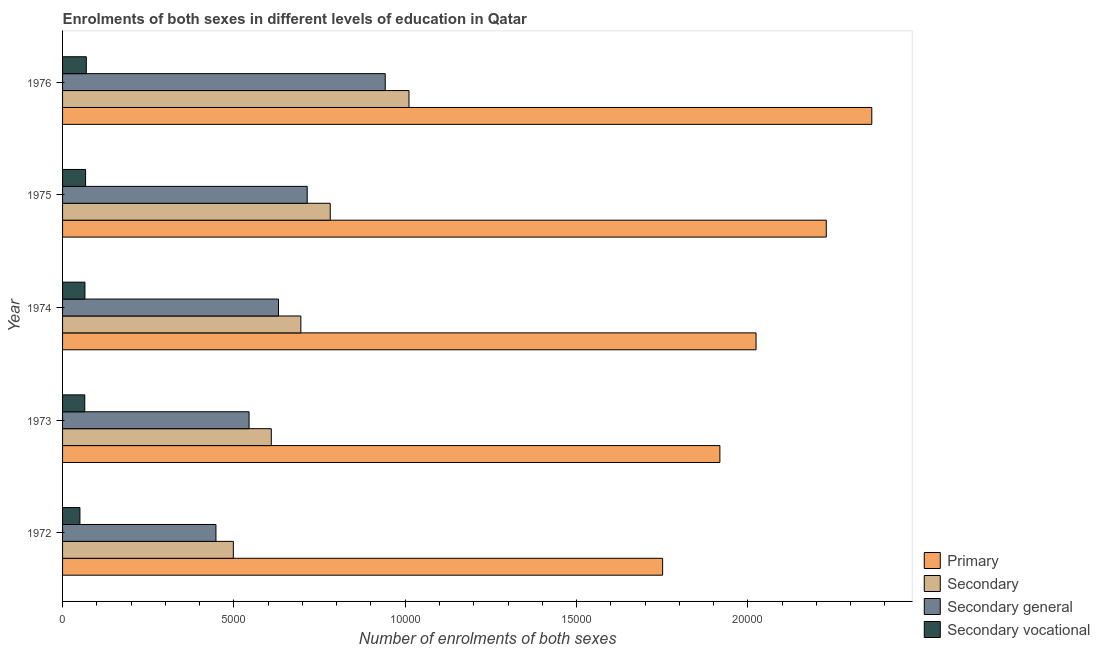Are the number of bars on each tick of the Y-axis equal?
Your answer should be very brief. Yes. How many bars are there on the 4th tick from the top?
Provide a short and direct response. 4. How many bars are there on the 4th tick from the bottom?
Ensure brevity in your answer.  4. What is the label of the 4th group of bars from the top?
Your answer should be very brief. 1973. What is the number of enrolments in secondary vocational education in 1975?
Provide a succinct answer. 672. Across all years, what is the maximum number of enrolments in secondary general education?
Make the answer very short. 9416. Across all years, what is the minimum number of enrolments in secondary general education?
Your answer should be very brief. 4476. In which year was the number of enrolments in primary education maximum?
Offer a very short reply. 1976. In which year was the number of enrolments in secondary general education minimum?
Make the answer very short. 1972. What is the total number of enrolments in secondary education in the graph?
Keep it short and to the point. 3.59e+04. What is the difference between the number of enrolments in secondary vocational education in 1974 and that in 1976?
Make the answer very short. -40. What is the difference between the number of enrolments in secondary vocational education in 1972 and the number of enrolments in primary education in 1974?
Offer a very short reply. -1.97e+04. What is the average number of enrolments in secondary general education per year?
Provide a short and direct response. 6555. In the year 1973, what is the difference between the number of enrolments in secondary education and number of enrolments in primary education?
Keep it short and to the point. -1.31e+04. In how many years, is the number of enrolments in primary education greater than 9000 ?
Provide a succinct answer. 5. What is the ratio of the number of enrolments in primary education in 1973 to that in 1974?
Provide a succinct answer. 0.95. What is the difference between the highest and the second highest number of enrolments in secondary education?
Give a very brief answer. 2298. What is the difference between the highest and the lowest number of enrolments in secondary education?
Make the answer very short. 5126. In how many years, is the number of enrolments in secondary education greater than the average number of enrolments in secondary education taken over all years?
Provide a succinct answer. 2. Is it the case that in every year, the sum of the number of enrolments in primary education and number of enrolments in secondary education is greater than the sum of number of enrolments in secondary vocational education and number of enrolments in secondary general education?
Make the answer very short. No. What does the 4th bar from the top in 1974 represents?
Make the answer very short. Primary. What does the 4th bar from the bottom in 1974 represents?
Provide a succinct answer. Secondary vocational. Are all the bars in the graph horizontal?
Keep it short and to the point. Yes. How many years are there in the graph?
Offer a terse response. 5. What is the difference between two consecutive major ticks on the X-axis?
Your answer should be compact. 5000. Are the values on the major ticks of X-axis written in scientific E-notation?
Provide a short and direct response. No. Does the graph contain any zero values?
Offer a terse response. No. Does the graph contain grids?
Offer a very short reply. No. How are the legend labels stacked?
Keep it short and to the point. Vertical. What is the title of the graph?
Provide a succinct answer. Enrolments of both sexes in different levels of education in Qatar. What is the label or title of the X-axis?
Keep it short and to the point. Number of enrolments of both sexes. What is the Number of enrolments of both sexes of Primary in 1972?
Offer a terse response. 1.75e+04. What is the Number of enrolments of both sexes of Secondary in 1972?
Provide a short and direct response. 4983. What is the Number of enrolments of both sexes of Secondary general in 1972?
Offer a very short reply. 4476. What is the Number of enrolments of both sexes of Secondary vocational in 1972?
Ensure brevity in your answer.  507. What is the Number of enrolments of both sexes of Primary in 1973?
Make the answer very short. 1.92e+04. What is the Number of enrolments of both sexes in Secondary in 1973?
Keep it short and to the point. 6091. What is the Number of enrolments of both sexes of Secondary general in 1973?
Provide a succinct answer. 5443. What is the Number of enrolments of both sexes in Secondary vocational in 1973?
Your response must be concise. 648. What is the Number of enrolments of both sexes in Primary in 1974?
Offer a very short reply. 2.02e+04. What is the Number of enrolments of both sexes in Secondary in 1974?
Your answer should be very brief. 6954. What is the Number of enrolments of both sexes of Secondary general in 1974?
Your answer should be very brief. 6301. What is the Number of enrolments of both sexes in Secondary vocational in 1974?
Your answer should be very brief. 653. What is the Number of enrolments of both sexes in Primary in 1975?
Offer a terse response. 2.23e+04. What is the Number of enrolments of both sexes in Secondary in 1975?
Your answer should be compact. 7811. What is the Number of enrolments of both sexes in Secondary general in 1975?
Provide a succinct answer. 7139. What is the Number of enrolments of both sexes of Secondary vocational in 1975?
Ensure brevity in your answer.  672. What is the Number of enrolments of both sexes in Primary in 1976?
Your response must be concise. 2.36e+04. What is the Number of enrolments of both sexes of Secondary in 1976?
Give a very brief answer. 1.01e+04. What is the Number of enrolments of both sexes of Secondary general in 1976?
Your answer should be very brief. 9416. What is the Number of enrolments of both sexes of Secondary vocational in 1976?
Give a very brief answer. 693. Across all years, what is the maximum Number of enrolments of both sexes in Primary?
Keep it short and to the point. 2.36e+04. Across all years, what is the maximum Number of enrolments of both sexes in Secondary?
Your answer should be compact. 1.01e+04. Across all years, what is the maximum Number of enrolments of both sexes of Secondary general?
Your answer should be very brief. 9416. Across all years, what is the maximum Number of enrolments of both sexes in Secondary vocational?
Offer a very short reply. 693. Across all years, what is the minimum Number of enrolments of both sexes in Primary?
Your answer should be very brief. 1.75e+04. Across all years, what is the minimum Number of enrolments of both sexes of Secondary?
Make the answer very short. 4983. Across all years, what is the minimum Number of enrolments of both sexes of Secondary general?
Provide a short and direct response. 4476. Across all years, what is the minimum Number of enrolments of both sexes of Secondary vocational?
Offer a very short reply. 507. What is the total Number of enrolments of both sexes of Primary in the graph?
Make the answer very short. 1.03e+05. What is the total Number of enrolments of both sexes of Secondary in the graph?
Your answer should be compact. 3.59e+04. What is the total Number of enrolments of both sexes of Secondary general in the graph?
Make the answer very short. 3.28e+04. What is the total Number of enrolments of both sexes of Secondary vocational in the graph?
Give a very brief answer. 3173. What is the difference between the Number of enrolments of both sexes in Primary in 1972 and that in 1973?
Keep it short and to the point. -1671. What is the difference between the Number of enrolments of both sexes in Secondary in 1972 and that in 1973?
Offer a terse response. -1108. What is the difference between the Number of enrolments of both sexes of Secondary general in 1972 and that in 1973?
Your response must be concise. -967. What is the difference between the Number of enrolments of both sexes in Secondary vocational in 1972 and that in 1973?
Ensure brevity in your answer.  -141. What is the difference between the Number of enrolments of both sexes of Primary in 1972 and that in 1974?
Your response must be concise. -2726. What is the difference between the Number of enrolments of both sexes in Secondary in 1972 and that in 1974?
Provide a short and direct response. -1971. What is the difference between the Number of enrolments of both sexes in Secondary general in 1972 and that in 1974?
Provide a short and direct response. -1825. What is the difference between the Number of enrolments of both sexes in Secondary vocational in 1972 and that in 1974?
Your answer should be compact. -146. What is the difference between the Number of enrolments of both sexes in Primary in 1972 and that in 1975?
Your response must be concise. -4776. What is the difference between the Number of enrolments of both sexes of Secondary in 1972 and that in 1975?
Your answer should be compact. -2828. What is the difference between the Number of enrolments of both sexes of Secondary general in 1972 and that in 1975?
Offer a terse response. -2663. What is the difference between the Number of enrolments of both sexes in Secondary vocational in 1972 and that in 1975?
Offer a terse response. -165. What is the difference between the Number of enrolments of both sexes in Primary in 1972 and that in 1976?
Keep it short and to the point. -6104. What is the difference between the Number of enrolments of both sexes in Secondary in 1972 and that in 1976?
Offer a terse response. -5126. What is the difference between the Number of enrolments of both sexes of Secondary general in 1972 and that in 1976?
Provide a succinct answer. -4940. What is the difference between the Number of enrolments of both sexes of Secondary vocational in 1972 and that in 1976?
Make the answer very short. -186. What is the difference between the Number of enrolments of both sexes of Primary in 1973 and that in 1974?
Offer a terse response. -1055. What is the difference between the Number of enrolments of both sexes in Secondary in 1973 and that in 1974?
Keep it short and to the point. -863. What is the difference between the Number of enrolments of both sexes in Secondary general in 1973 and that in 1974?
Provide a short and direct response. -858. What is the difference between the Number of enrolments of both sexes of Primary in 1973 and that in 1975?
Ensure brevity in your answer.  -3105. What is the difference between the Number of enrolments of both sexes in Secondary in 1973 and that in 1975?
Provide a succinct answer. -1720. What is the difference between the Number of enrolments of both sexes in Secondary general in 1973 and that in 1975?
Offer a very short reply. -1696. What is the difference between the Number of enrolments of both sexes in Secondary vocational in 1973 and that in 1975?
Ensure brevity in your answer.  -24. What is the difference between the Number of enrolments of both sexes in Primary in 1973 and that in 1976?
Provide a short and direct response. -4433. What is the difference between the Number of enrolments of both sexes of Secondary in 1973 and that in 1976?
Your answer should be very brief. -4018. What is the difference between the Number of enrolments of both sexes of Secondary general in 1973 and that in 1976?
Provide a succinct answer. -3973. What is the difference between the Number of enrolments of both sexes of Secondary vocational in 1973 and that in 1976?
Offer a very short reply. -45. What is the difference between the Number of enrolments of both sexes of Primary in 1974 and that in 1975?
Keep it short and to the point. -2050. What is the difference between the Number of enrolments of both sexes of Secondary in 1974 and that in 1975?
Provide a succinct answer. -857. What is the difference between the Number of enrolments of both sexes in Secondary general in 1974 and that in 1975?
Your answer should be compact. -838. What is the difference between the Number of enrolments of both sexes in Primary in 1974 and that in 1976?
Offer a very short reply. -3378. What is the difference between the Number of enrolments of both sexes in Secondary in 1974 and that in 1976?
Your answer should be compact. -3155. What is the difference between the Number of enrolments of both sexes in Secondary general in 1974 and that in 1976?
Provide a succinct answer. -3115. What is the difference between the Number of enrolments of both sexes in Primary in 1975 and that in 1976?
Ensure brevity in your answer.  -1328. What is the difference between the Number of enrolments of both sexes in Secondary in 1975 and that in 1976?
Give a very brief answer. -2298. What is the difference between the Number of enrolments of both sexes of Secondary general in 1975 and that in 1976?
Your answer should be very brief. -2277. What is the difference between the Number of enrolments of both sexes in Secondary vocational in 1975 and that in 1976?
Your answer should be compact. -21. What is the difference between the Number of enrolments of both sexes of Primary in 1972 and the Number of enrolments of both sexes of Secondary in 1973?
Your response must be concise. 1.14e+04. What is the difference between the Number of enrolments of both sexes of Primary in 1972 and the Number of enrolments of both sexes of Secondary general in 1973?
Offer a very short reply. 1.21e+04. What is the difference between the Number of enrolments of both sexes of Primary in 1972 and the Number of enrolments of both sexes of Secondary vocational in 1973?
Keep it short and to the point. 1.69e+04. What is the difference between the Number of enrolments of both sexes in Secondary in 1972 and the Number of enrolments of both sexes in Secondary general in 1973?
Give a very brief answer. -460. What is the difference between the Number of enrolments of both sexes of Secondary in 1972 and the Number of enrolments of both sexes of Secondary vocational in 1973?
Make the answer very short. 4335. What is the difference between the Number of enrolments of both sexes in Secondary general in 1972 and the Number of enrolments of both sexes in Secondary vocational in 1973?
Provide a succinct answer. 3828. What is the difference between the Number of enrolments of both sexes in Primary in 1972 and the Number of enrolments of both sexes in Secondary in 1974?
Offer a very short reply. 1.06e+04. What is the difference between the Number of enrolments of both sexes in Primary in 1972 and the Number of enrolments of both sexes in Secondary general in 1974?
Provide a succinct answer. 1.12e+04. What is the difference between the Number of enrolments of both sexes in Primary in 1972 and the Number of enrolments of both sexes in Secondary vocational in 1974?
Your answer should be compact. 1.69e+04. What is the difference between the Number of enrolments of both sexes of Secondary in 1972 and the Number of enrolments of both sexes of Secondary general in 1974?
Give a very brief answer. -1318. What is the difference between the Number of enrolments of both sexes in Secondary in 1972 and the Number of enrolments of both sexes in Secondary vocational in 1974?
Make the answer very short. 4330. What is the difference between the Number of enrolments of both sexes of Secondary general in 1972 and the Number of enrolments of both sexes of Secondary vocational in 1974?
Offer a very short reply. 3823. What is the difference between the Number of enrolments of both sexes of Primary in 1972 and the Number of enrolments of both sexes of Secondary in 1975?
Keep it short and to the point. 9700. What is the difference between the Number of enrolments of both sexes in Primary in 1972 and the Number of enrolments of both sexes in Secondary general in 1975?
Give a very brief answer. 1.04e+04. What is the difference between the Number of enrolments of both sexes of Primary in 1972 and the Number of enrolments of both sexes of Secondary vocational in 1975?
Offer a very short reply. 1.68e+04. What is the difference between the Number of enrolments of both sexes of Secondary in 1972 and the Number of enrolments of both sexes of Secondary general in 1975?
Your answer should be very brief. -2156. What is the difference between the Number of enrolments of both sexes in Secondary in 1972 and the Number of enrolments of both sexes in Secondary vocational in 1975?
Provide a short and direct response. 4311. What is the difference between the Number of enrolments of both sexes of Secondary general in 1972 and the Number of enrolments of both sexes of Secondary vocational in 1975?
Your answer should be very brief. 3804. What is the difference between the Number of enrolments of both sexes of Primary in 1972 and the Number of enrolments of both sexes of Secondary in 1976?
Offer a very short reply. 7402. What is the difference between the Number of enrolments of both sexes in Primary in 1972 and the Number of enrolments of both sexes in Secondary general in 1976?
Your answer should be very brief. 8095. What is the difference between the Number of enrolments of both sexes in Primary in 1972 and the Number of enrolments of both sexes in Secondary vocational in 1976?
Give a very brief answer. 1.68e+04. What is the difference between the Number of enrolments of both sexes in Secondary in 1972 and the Number of enrolments of both sexes in Secondary general in 1976?
Offer a very short reply. -4433. What is the difference between the Number of enrolments of both sexes in Secondary in 1972 and the Number of enrolments of both sexes in Secondary vocational in 1976?
Offer a very short reply. 4290. What is the difference between the Number of enrolments of both sexes of Secondary general in 1972 and the Number of enrolments of both sexes of Secondary vocational in 1976?
Provide a short and direct response. 3783. What is the difference between the Number of enrolments of both sexes of Primary in 1973 and the Number of enrolments of both sexes of Secondary in 1974?
Provide a short and direct response. 1.22e+04. What is the difference between the Number of enrolments of both sexes of Primary in 1973 and the Number of enrolments of both sexes of Secondary general in 1974?
Provide a short and direct response. 1.29e+04. What is the difference between the Number of enrolments of both sexes of Primary in 1973 and the Number of enrolments of both sexes of Secondary vocational in 1974?
Your answer should be compact. 1.85e+04. What is the difference between the Number of enrolments of both sexes in Secondary in 1973 and the Number of enrolments of both sexes in Secondary general in 1974?
Offer a very short reply. -210. What is the difference between the Number of enrolments of both sexes in Secondary in 1973 and the Number of enrolments of both sexes in Secondary vocational in 1974?
Your answer should be compact. 5438. What is the difference between the Number of enrolments of both sexes of Secondary general in 1973 and the Number of enrolments of both sexes of Secondary vocational in 1974?
Provide a succinct answer. 4790. What is the difference between the Number of enrolments of both sexes of Primary in 1973 and the Number of enrolments of both sexes of Secondary in 1975?
Make the answer very short. 1.14e+04. What is the difference between the Number of enrolments of both sexes in Primary in 1973 and the Number of enrolments of both sexes in Secondary general in 1975?
Offer a very short reply. 1.20e+04. What is the difference between the Number of enrolments of both sexes of Primary in 1973 and the Number of enrolments of both sexes of Secondary vocational in 1975?
Your response must be concise. 1.85e+04. What is the difference between the Number of enrolments of both sexes in Secondary in 1973 and the Number of enrolments of both sexes in Secondary general in 1975?
Your response must be concise. -1048. What is the difference between the Number of enrolments of both sexes of Secondary in 1973 and the Number of enrolments of both sexes of Secondary vocational in 1975?
Give a very brief answer. 5419. What is the difference between the Number of enrolments of both sexes in Secondary general in 1973 and the Number of enrolments of both sexes in Secondary vocational in 1975?
Offer a terse response. 4771. What is the difference between the Number of enrolments of both sexes in Primary in 1973 and the Number of enrolments of both sexes in Secondary in 1976?
Provide a succinct answer. 9073. What is the difference between the Number of enrolments of both sexes in Primary in 1973 and the Number of enrolments of both sexes in Secondary general in 1976?
Provide a succinct answer. 9766. What is the difference between the Number of enrolments of both sexes in Primary in 1973 and the Number of enrolments of both sexes in Secondary vocational in 1976?
Ensure brevity in your answer.  1.85e+04. What is the difference between the Number of enrolments of both sexes in Secondary in 1973 and the Number of enrolments of both sexes in Secondary general in 1976?
Your response must be concise. -3325. What is the difference between the Number of enrolments of both sexes in Secondary in 1973 and the Number of enrolments of both sexes in Secondary vocational in 1976?
Ensure brevity in your answer.  5398. What is the difference between the Number of enrolments of both sexes of Secondary general in 1973 and the Number of enrolments of both sexes of Secondary vocational in 1976?
Offer a very short reply. 4750. What is the difference between the Number of enrolments of both sexes of Primary in 1974 and the Number of enrolments of both sexes of Secondary in 1975?
Make the answer very short. 1.24e+04. What is the difference between the Number of enrolments of both sexes in Primary in 1974 and the Number of enrolments of both sexes in Secondary general in 1975?
Your response must be concise. 1.31e+04. What is the difference between the Number of enrolments of both sexes in Primary in 1974 and the Number of enrolments of both sexes in Secondary vocational in 1975?
Give a very brief answer. 1.96e+04. What is the difference between the Number of enrolments of both sexes of Secondary in 1974 and the Number of enrolments of both sexes of Secondary general in 1975?
Provide a short and direct response. -185. What is the difference between the Number of enrolments of both sexes of Secondary in 1974 and the Number of enrolments of both sexes of Secondary vocational in 1975?
Provide a short and direct response. 6282. What is the difference between the Number of enrolments of both sexes of Secondary general in 1974 and the Number of enrolments of both sexes of Secondary vocational in 1975?
Your answer should be very brief. 5629. What is the difference between the Number of enrolments of both sexes of Primary in 1974 and the Number of enrolments of both sexes of Secondary in 1976?
Your response must be concise. 1.01e+04. What is the difference between the Number of enrolments of both sexes in Primary in 1974 and the Number of enrolments of both sexes in Secondary general in 1976?
Your response must be concise. 1.08e+04. What is the difference between the Number of enrolments of both sexes in Primary in 1974 and the Number of enrolments of both sexes in Secondary vocational in 1976?
Provide a short and direct response. 1.95e+04. What is the difference between the Number of enrolments of both sexes of Secondary in 1974 and the Number of enrolments of both sexes of Secondary general in 1976?
Keep it short and to the point. -2462. What is the difference between the Number of enrolments of both sexes in Secondary in 1974 and the Number of enrolments of both sexes in Secondary vocational in 1976?
Provide a short and direct response. 6261. What is the difference between the Number of enrolments of both sexes in Secondary general in 1974 and the Number of enrolments of both sexes in Secondary vocational in 1976?
Provide a short and direct response. 5608. What is the difference between the Number of enrolments of both sexes in Primary in 1975 and the Number of enrolments of both sexes in Secondary in 1976?
Provide a short and direct response. 1.22e+04. What is the difference between the Number of enrolments of both sexes in Primary in 1975 and the Number of enrolments of both sexes in Secondary general in 1976?
Offer a very short reply. 1.29e+04. What is the difference between the Number of enrolments of both sexes of Primary in 1975 and the Number of enrolments of both sexes of Secondary vocational in 1976?
Your response must be concise. 2.16e+04. What is the difference between the Number of enrolments of both sexes in Secondary in 1975 and the Number of enrolments of both sexes in Secondary general in 1976?
Give a very brief answer. -1605. What is the difference between the Number of enrolments of both sexes of Secondary in 1975 and the Number of enrolments of both sexes of Secondary vocational in 1976?
Provide a succinct answer. 7118. What is the difference between the Number of enrolments of both sexes in Secondary general in 1975 and the Number of enrolments of both sexes in Secondary vocational in 1976?
Make the answer very short. 6446. What is the average Number of enrolments of both sexes of Primary per year?
Keep it short and to the point. 2.06e+04. What is the average Number of enrolments of both sexes in Secondary per year?
Offer a terse response. 7189.6. What is the average Number of enrolments of both sexes in Secondary general per year?
Keep it short and to the point. 6555. What is the average Number of enrolments of both sexes in Secondary vocational per year?
Give a very brief answer. 634.6. In the year 1972, what is the difference between the Number of enrolments of both sexes in Primary and Number of enrolments of both sexes in Secondary?
Offer a very short reply. 1.25e+04. In the year 1972, what is the difference between the Number of enrolments of both sexes in Primary and Number of enrolments of both sexes in Secondary general?
Give a very brief answer. 1.30e+04. In the year 1972, what is the difference between the Number of enrolments of both sexes in Primary and Number of enrolments of both sexes in Secondary vocational?
Ensure brevity in your answer.  1.70e+04. In the year 1972, what is the difference between the Number of enrolments of both sexes in Secondary and Number of enrolments of both sexes in Secondary general?
Offer a terse response. 507. In the year 1972, what is the difference between the Number of enrolments of both sexes of Secondary and Number of enrolments of both sexes of Secondary vocational?
Provide a succinct answer. 4476. In the year 1972, what is the difference between the Number of enrolments of both sexes in Secondary general and Number of enrolments of both sexes in Secondary vocational?
Give a very brief answer. 3969. In the year 1973, what is the difference between the Number of enrolments of both sexes of Primary and Number of enrolments of both sexes of Secondary?
Keep it short and to the point. 1.31e+04. In the year 1973, what is the difference between the Number of enrolments of both sexes of Primary and Number of enrolments of both sexes of Secondary general?
Your answer should be very brief. 1.37e+04. In the year 1973, what is the difference between the Number of enrolments of both sexes of Primary and Number of enrolments of both sexes of Secondary vocational?
Provide a short and direct response. 1.85e+04. In the year 1973, what is the difference between the Number of enrolments of both sexes of Secondary and Number of enrolments of both sexes of Secondary general?
Your answer should be compact. 648. In the year 1973, what is the difference between the Number of enrolments of both sexes of Secondary and Number of enrolments of both sexes of Secondary vocational?
Your response must be concise. 5443. In the year 1973, what is the difference between the Number of enrolments of both sexes in Secondary general and Number of enrolments of both sexes in Secondary vocational?
Your response must be concise. 4795. In the year 1974, what is the difference between the Number of enrolments of both sexes in Primary and Number of enrolments of both sexes in Secondary?
Give a very brief answer. 1.33e+04. In the year 1974, what is the difference between the Number of enrolments of both sexes in Primary and Number of enrolments of both sexes in Secondary general?
Offer a terse response. 1.39e+04. In the year 1974, what is the difference between the Number of enrolments of both sexes of Primary and Number of enrolments of both sexes of Secondary vocational?
Provide a short and direct response. 1.96e+04. In the year 1974, what is the difference between the Number of enrolments of both sexes in Secondary and Number of enrolments of both sexes in Secondary general?
Provide a succinct answer. 653. In the year 1974, what is the difference between the Number of enrolments of both sexes in Secondary and Number of enrolments of both sexes in Secondary vocational?
Your response must be concise. 6301. In the year 1974, what is the difference between the Number of enrolments of both sexes of Secondary general and Number of enrolments of both sexes of Secondary vocational?
Give a very brief answer. 5648. In the year 1975, what is the difference between the Number of enrolments of both sexes of Primary and Number of enrolments of both sexes of Secondary?
Provide a succinct answer. 1.45e+04. In the year 1975, what is the difference between the Number of enrolments of both sexes of Primary and Number of enrolments of both sexes of Secondary general?
Give a very brief answer. 1.51e+04. In the year 1975, what is the difference between the Number of enrolments of both sexes of Primary and Number of enrolments of both sexes of Secondary vocational?
Keep it short and to the point. 2.16e+04. In the year 1975, what is the difference between the Number of enrolments of both sexes in Secondary and Number of enrolments of both sexes in Secondary general?
Provide a short and direct response. 672. In the year 1975, what is the difference between the Number of enrolments of both sexes of Secondary and Number of enrolments of both sexes of Secondary vocational?
Make the answer very short. 7139. In the year 1975, what is the difference between the Number of enrolments of both sexes of Secondary general and Number of enrolments of both sexes of Secondary vocational?
Your response must be concise. 6467. In the year 1976, what is the difference between the Number of enrolments of both sexes in Primary and Number of enrolments of both sexes in Secondary?
Provide a short and direct response. 1.35e+04. In the year 1976, what is the difference between the Number of enrolments of both sexes in Primary and Number of enrolments of both sexes in Secondary general?
Keep it short and to the point. 1.42e+04. In the year 1976, what is the difference between the Number of enrolments of both sexes of Primary and Number of enrolments of both sexes of Secondary vocational?
Ensure brevity in your answer.  2.29e+04. In the year 1976, what is the difference between the Number of enrolments of both sexes in Secondary and Number of enrolments of both sexes in Secondary general?
Keep it short and to the point. 693. In the year 1976, what is the difference between the Number of enrolments of both sexes in Secondary and Number of enrolments of both sexes in Secondary vocational?
Your response must be concise. 9416. In the year 1976, what is the difference between the Number of enrolments of both sexes of Secondary general and Number of enrolments of both sexes of Secondary vocational?
Keep it short and to the point. 8723. What is the ratio of the Number of enrolments of both sexes of Primary in 1972 to that in 1973?
Offer a very short reply. 0.91. What is the ratio of the Number of enrolments of both sexes of Secondary in 1972 to that in 1973?
Provide a short and direct response. 0.82. What is the ratio of the Number of enrolments of both sexes in Secondary general in 1972 to that in 1973?
Offer a terse response. 0.82. What is the ratio of the Number of enrolments of both sexes in Secondary vocational in 1972 to that in 1973?
Keep it short and to the point. 0.78. What is the ratio of the Number of enrolments of both sexes in Primary in 1972 to that in 1974?
Your answer should be very brief. 0.87. What is the ratio of the Number of enrolments of both sexes of Secondary in 1972 to that in 1974?
Provide a succinct answer. 0.72. What is the ratio of the Number of enrolments of both sexes of Secondary general in 1972 to that in 1974?
Offer a very short reply. 0.71. What is the ratio of the Number of enrolments of both sexes of Secondary vocational in 1972 to that in 1974?
Your response must be concise. 0.78. What is the ratio of the Number of enrolments of both sexes of Primary in 1972 to that in 1975?
Ensure brevity in your answer.  0.79. What is the ratio of the Number of enrolments of both sexes of Secondary in 1972 to that in 1975?
Ensure brevity in your answer.  0.64. What is the ratio of the Number of enrolments of both sexes of Secondary general in 1972 to that in 1975?
Offer a terse response. 0.63. What is the ratio of the Number of enrolments of both sexes of Secondary vocational in 1972 to that in 1975?
Offer a very short reply. 0.75. What is the ratio of the Number of enrolments of both sexes in Primary in 1972 to that in 1976?
Make the answer very short. 0.74. What is the ratio of the Number of enrolments of both sexes of Secondary in 1972 to that in 1976?
Your answer should be very brief. 0.49. What is the ratio of the Number of enrolments of both sexes in Secondary general in 1972 to that in 1976?
Offer a very short reply. 0.48. What is the ratio of the Number of enrolments of both sexes of Secondary vocational in 1972 to that in 1976?
Provide a short and direct response. 0.73. What is the ratio of the Number of enrolments of both sexes of Primary in 1973 to that in 1974?
Ensure brevity in your answer.  0.95. What is the ratio of the Number of enrolments of both sexes of Secondary in 1973 to that in 1974?
Make the answer very short. 0.88. What is the ratio of the Number of enrolments of both sexes in Secondary general in 1973 to that in 1974?
Offer a very short reply. 0.86. What is the ratio of the Number of enrolments of both sexes in Primary in 1973 to that in 1975?
Offer a terse response. 0.86. What is the ratio of the Number of enrolments of both sexes in Secondary in 1973 to that in 1975?
Offer a terse response. 0.78. What is the ratio of the Number of enrolments of both sexes of Secondary general in 1973 to that in 1975?
Offer a terse response. 0.76. What is the ratio of the Number of enrolments of both sexes in Primary in 1973 to that in 1976?
Offer a very short reply. 0.81. What is the ratio of the Number of enrolments of both sexes of Secondary in 1973 to that in 1976?
Give a very brief answer. 0.6. What is the ratio of the Number of enrolments of both sexes of Secondary general in 1973 to that in 1976?
Your response must be concise. 0.58. What is the ratio of the Number of enrolments of both sexes in Secondary vocational in 1973 to that in 1976?
Your response must be concise. 0.94. What is the ratio of the Number of enrolments of both sexes in Primary in 1974 to that in 1975?
Give a very brief answer. 0.91. What is the ratio of the Number of enrolments of both sexes in Secondary in 1974 to that in 1975?
Keep it short and to the point. 0.89. What is the ratio of the Number of enrolments of both sexes of Secondary general in 1974 to that in 1975?
Your answer should be very brief. 0.88. What is the ratio of the Number of enrolments of both sexes of Secondary vocational in 1974 to that in 1975?
Your response must be concise. 0.97. What is the ratio of the Number of enrolments of both sexes of Primary in 1974 to that in 1976?
Your response must be concise. 0.86. What is the ratio of the Number of enrolments of both sexes of Secondary in 1974 to that in 1976?
Provide a succinct answer. 0.69. What is the ratio of the Number of enrolments of both sexes of Secondary general in 1974 to that in 1976?
Your answer should be very brief. 0.67. What is the ratio of the Number of enrolments of both sexes in Secondary vocational in 1974 to that in 1976?
Offer a very short reply. 0.94. What is the ratio of the Number of enrolments of both sexes of Primary in 1975 to that in 1976?
Offer a terse response. 0.94. What is the ratio of the Number of enrolments of both sexes of Secondary in 1975 to that in 1976?
Offer a terse response. 0.77. What is the ratio of the Number of enrolments of both sexes of Secondary general in 1975 to that in 1976?
Your answer should be compact. 0.76. What is the ratio of the Number of enrolments of both sexes in Secondary vocational in 1975 to that in 1976?
Your answer should be very brief. 0.97. What is the difference between the highest and the second highest Number of enrolments of both sexes of Primary?
Keep it short and to the point. 1328. What is the difference between the highest and the second highest Number of enrolments of both sexes of Secondary?
Make the answer very short. 2298. What is the difference between the highest and the second highest Number of enrolments of both sexes in Secondary general?
Give a very brief answer. 2277. What is the difference between the highest and the lowest Number of enrolments of both sexes of Primary?
Give a very brief answer. 6104. What is the difference between the highest and the lowest Number of enrolments of both sexes in Secondary?
Provide a succinct answer. 5126. What is the difference between the highest and the lowest Number of enrolments of both sexes in Secondary general?
Make the answer very short. 4940. What is the difference between the highest and the lowest Number of enrolments of both sexes of Secondary vocational?
Provide a succinct answer. 186. 